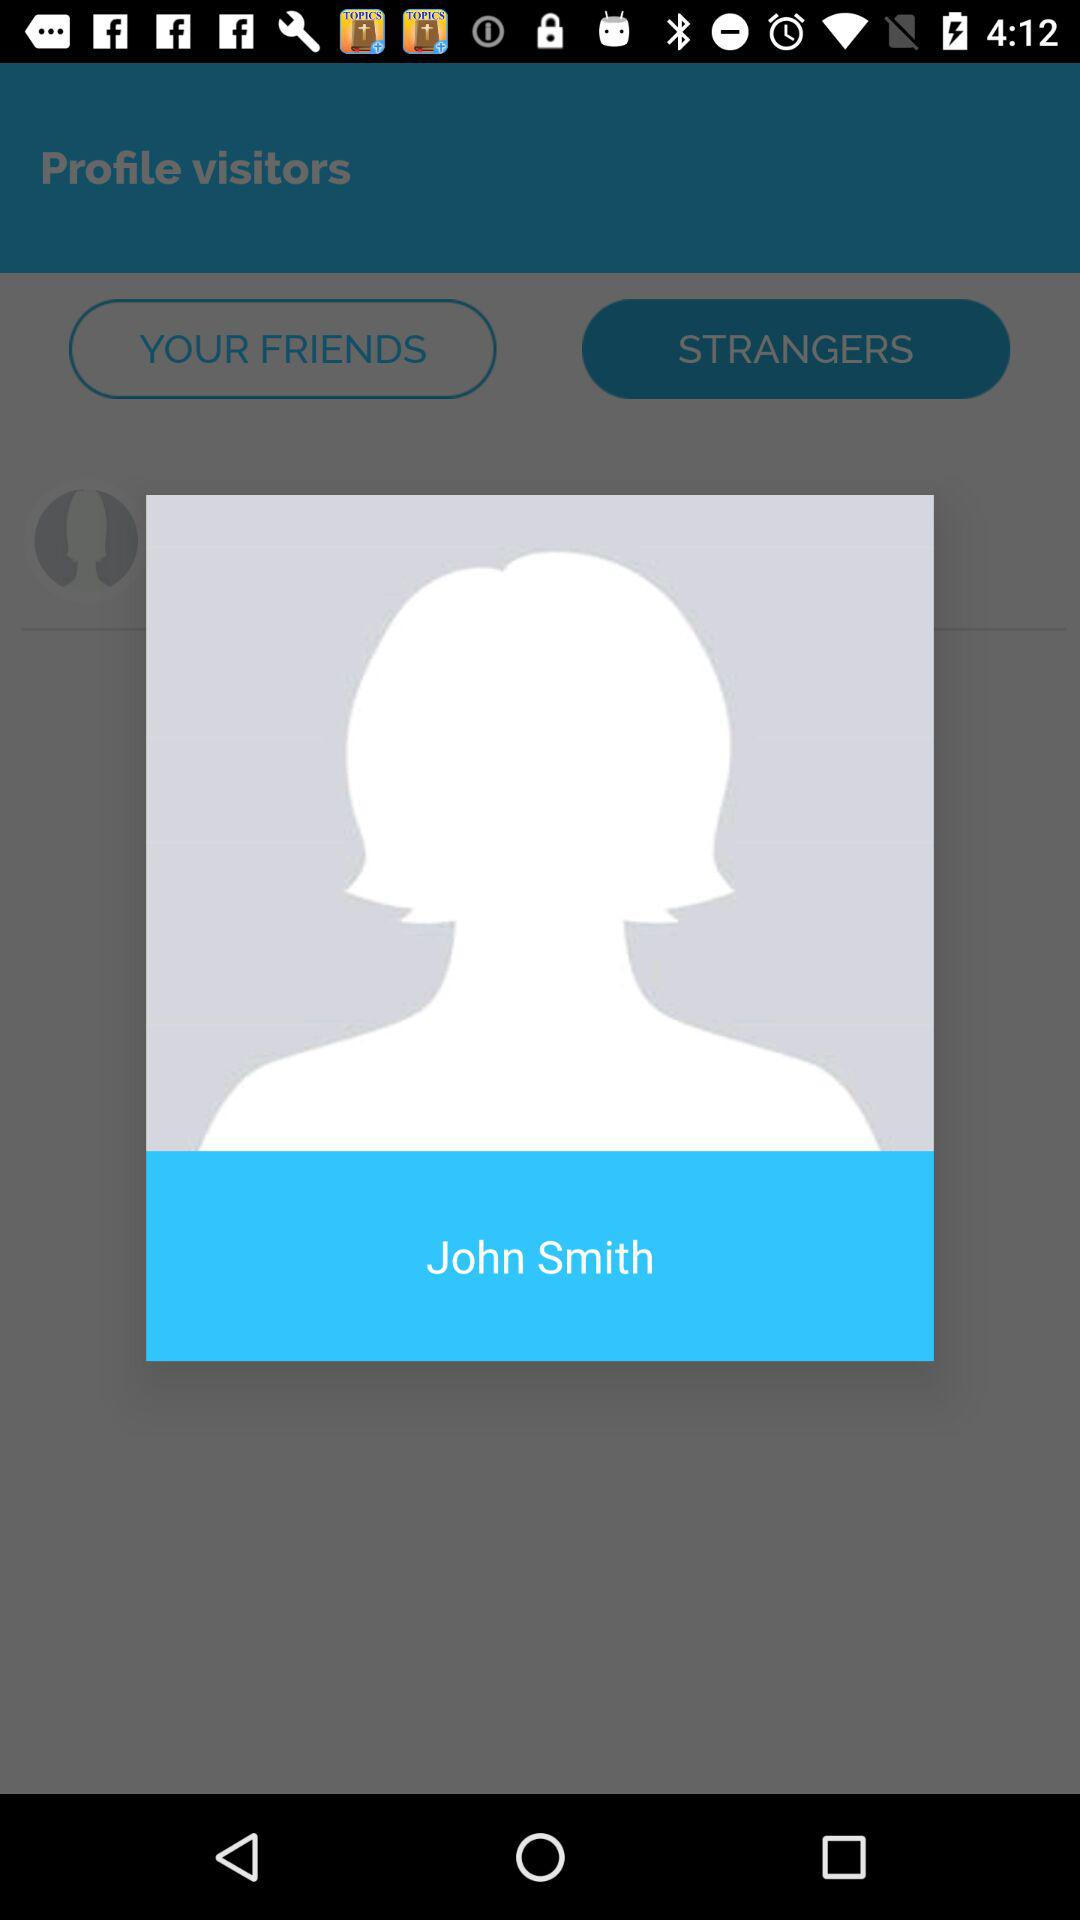What is the name of the profile? The name of the profile is John Smith. 